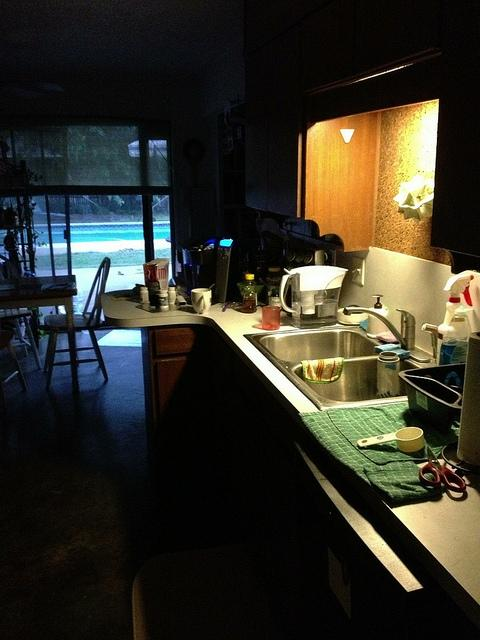What is to the right of the sink? Please explain your reasoning. scissors. The item is a pair of blades that pivot off a central point. 